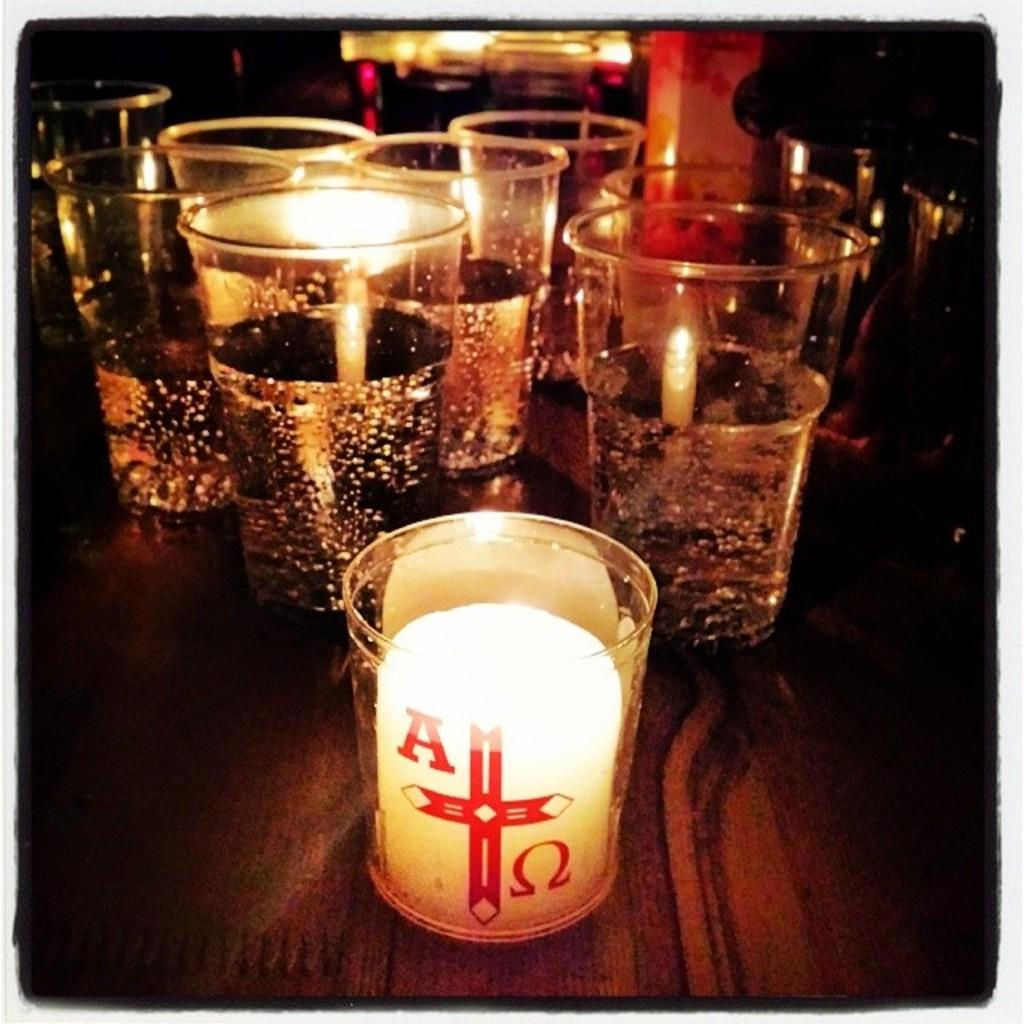What objects are present in the image? There are many glasses in the image. What is the color of the surface on which the glasses are placed? The glasses are on a brown color surface. Can you describe the background of the image? The background of the image is blurred. What memory does the monkey have about the glasses in the image? There is no monkey present in the image, so it cannot have any memory about the glasses. 